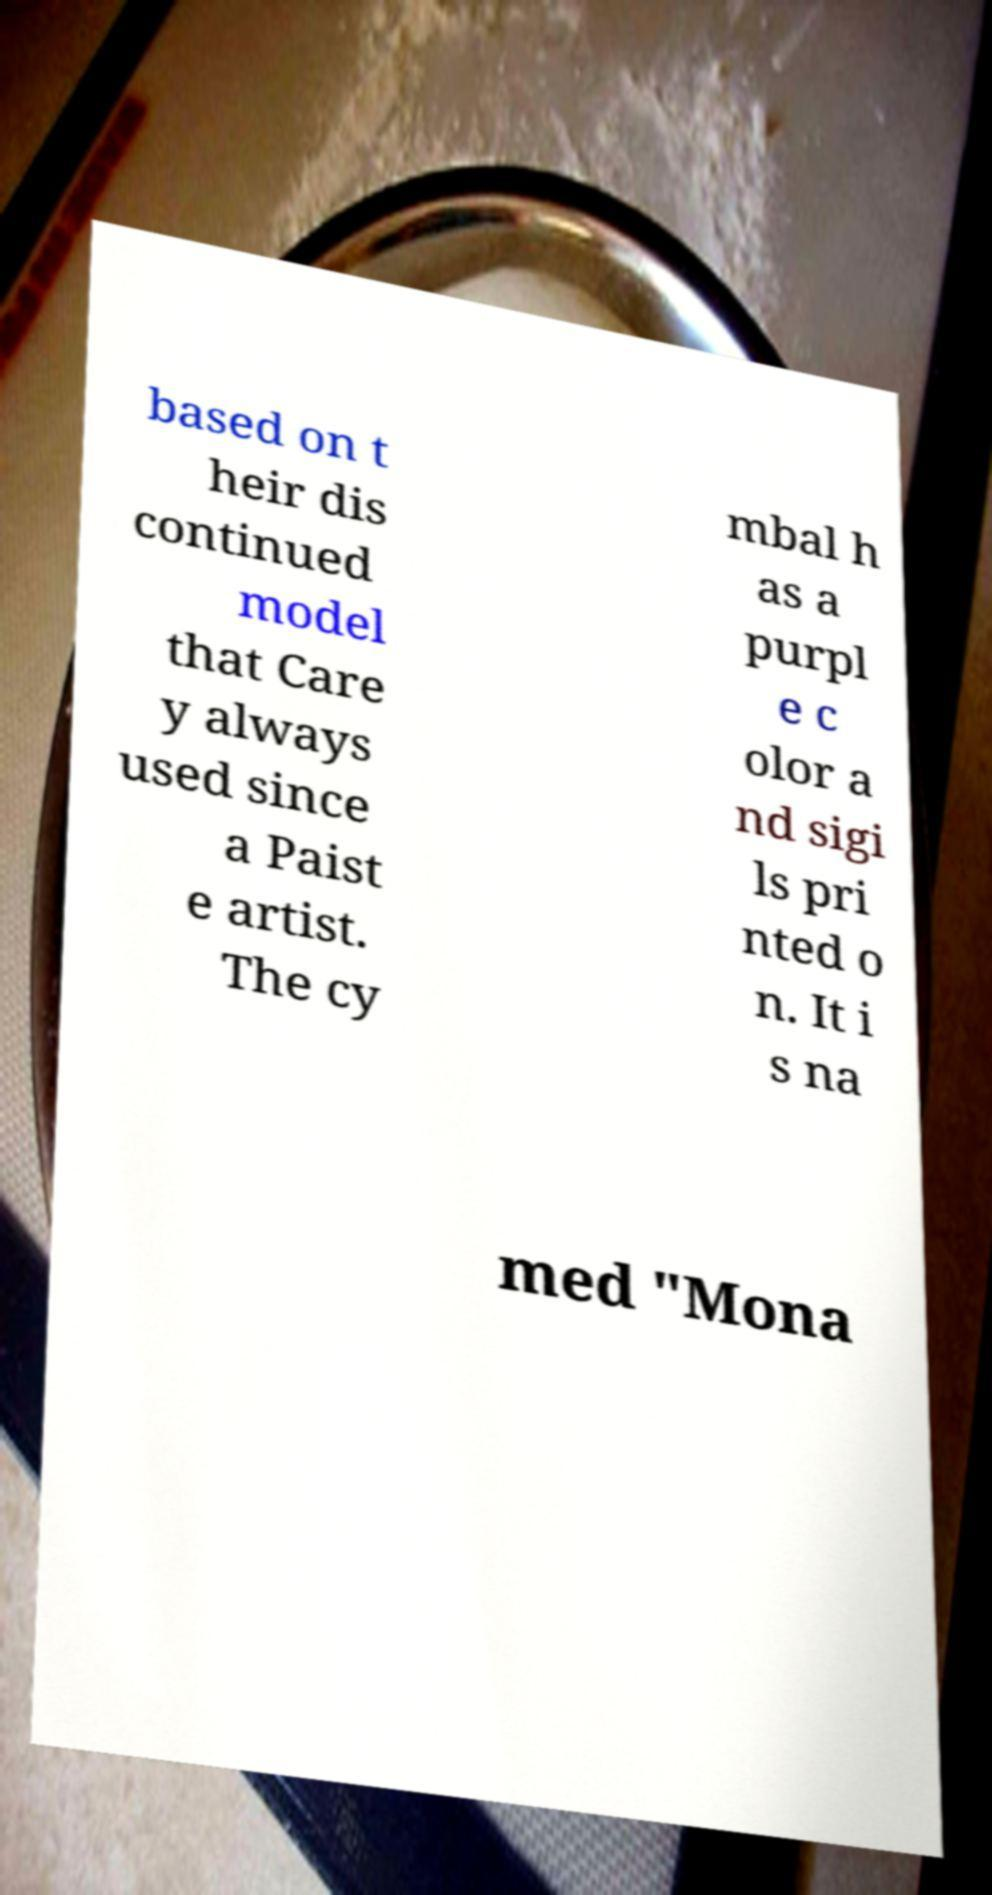I need the written content from this picture converted into text. Can you do that? based on t heir dis continued model that Care y always used since a Paist e artist. The cy mbal h as a purpl e c olor a nd sigi ls pri nted o n. It i s na med "Mona 